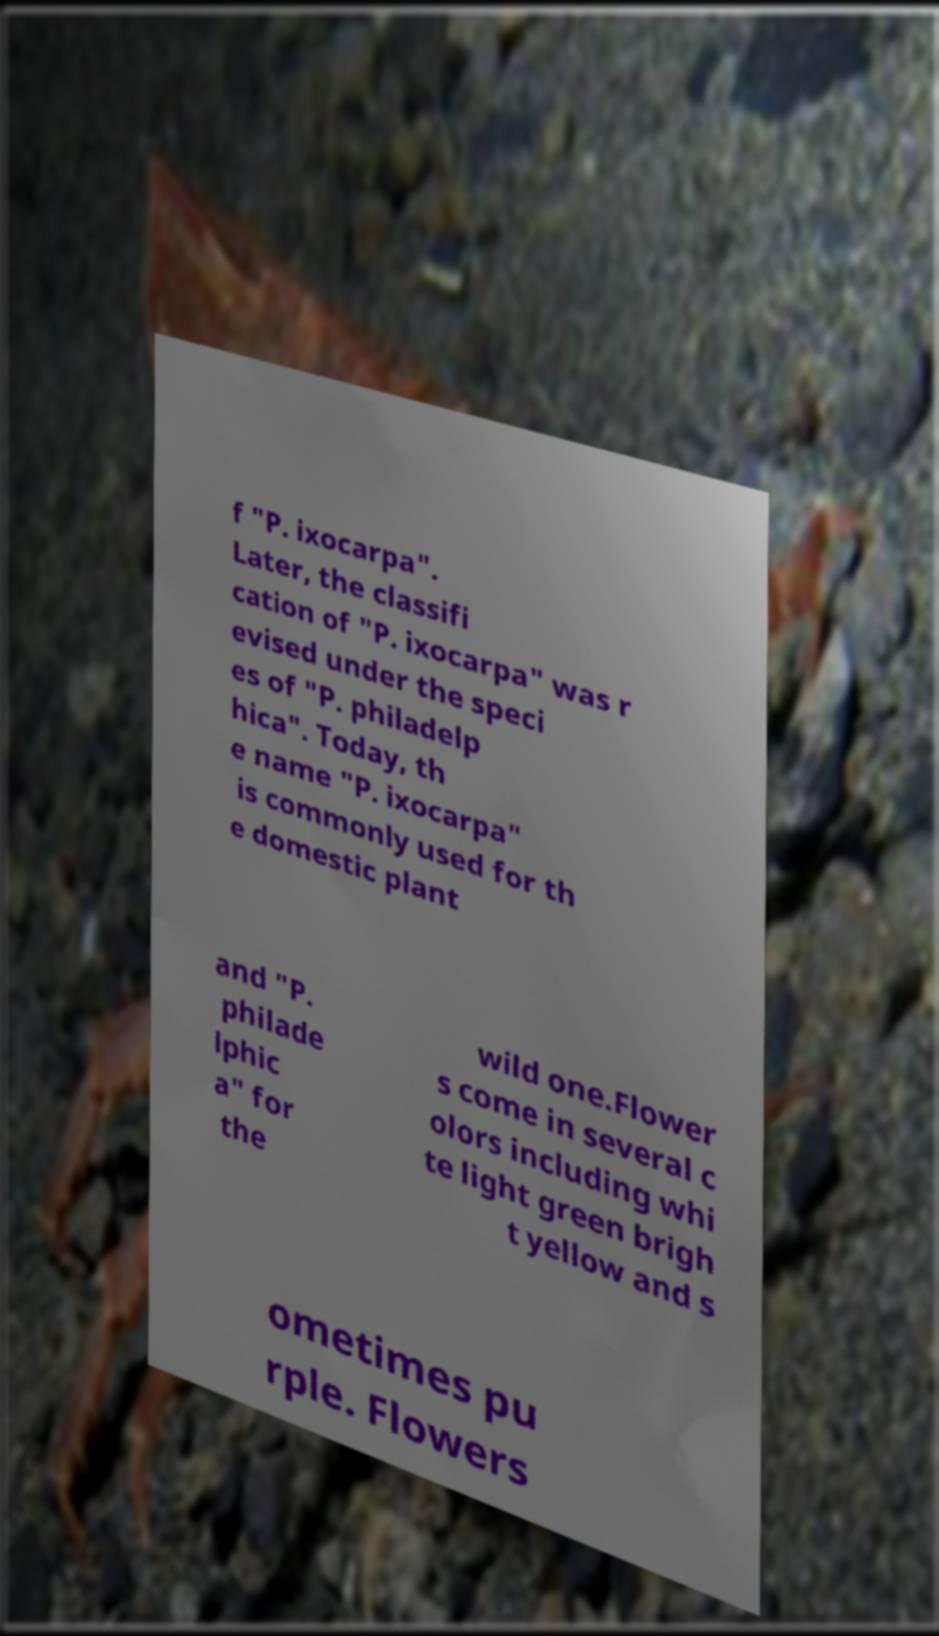I need the written content from this picture converted into text. Can you do that? f "P. ixocarpa". Later, the classifi cation of "P. ixocarpa" was r evised under the speci es of "P. philadelp hica". Today, th e name "P. ixocarpa" is commonly used for th e domestic plant and "P. philade lphic a" for the wild one.Flower s come in several c olors including whi te light green brigh t yellow and s ometimes pu rple. Flowers 